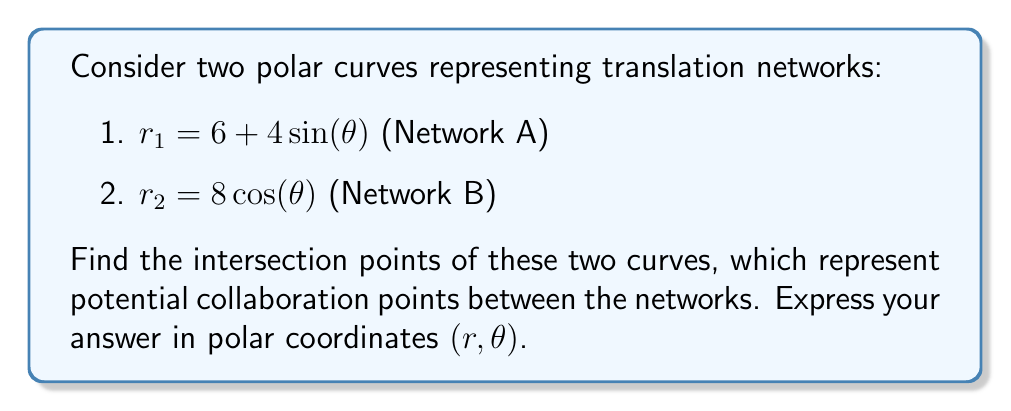Provide a solution to this math problem. To find the intersection points of these two polar curves, we need to solve the equation:

$$6 + 4\sin(\theta) = 8\cos(\theta)$$

Let's approach this step-by-step:

1) First, we rearrange the equation:
   $$6 = 8\cos(\theta) - 4\sin(\theta)$$

2) Divide both sides by 2:
   $$3 = 4\cos(\theta) - 2\sin(\theta)$$

3) We can use the trigonometric identity $a\cos(\theta) + b\sin(\theta) = R\cos(\theta - \alpha)$, where $R = \sqrt{a^2 + b^2}$ and $\tan(\alpha) = \frac{b}{a}$.

4) In our case, $a = 4$, $b = -2$:
   $$R = \sqrt{4^2 + (-2)^2} = \sqrt{20} = 2\sqrt{5}$$
   $$\tan(\alpha) = \frac{-2}{4} = -\frac{1}{2}$$
   $$\alpha = \arctan(-\frac{1}{2}) \approx -0.4636 \text{ radians}$$

5) Our equation becomes:
   $$3 = 2\sqrt{5}\cos(\theta + 0.4636)$$

6) Solving for $\theta$:
   $$\cos(\theta + 0.4636) = \frac{3}{2\sqrt{5}}$$
   $$\theta + 0.4636 = \pm \arccos(\frac{3}{2\sqrt{5}})$$
   $$\theta = -0.4636 \pm \arccos(\frac{3}{2\sqrt{5}})$$

7) This gives us two solutions:
   $$\theta_1 = -0.4636 + \arccos(\frac{3}{2\sqrt{5}}) \approx 0.7854 \text{ radians} = 45°$$
   $$\theta_2 = -0.4636 - \arccos(\frac{3}{2\sqrt{5}}) \approx -1.7126 \text{ radians} = -98.13°$$

8) To find the corresponding $r$ values, we can use either of the original equations. Let's use $r_1 = 6 + 4\sin(\theta)$:
   For $\theta_1$: $r_1 = 6 + 4\sin(45°) = 6 + 4 \cdot \frac{\sqrt{2}}{2} = 6 + 2\sqrt{2} \approx 8.8284$
   For $\theta_2$: $r_2 = 6 + 4\sin(-98.13°) \approx 2.8284$

Therefore, the intersection points are approximately $(8.8284, 45°)$ and $(2.8284, -98.13°)$ in polar coordinates $(r, \theta)$.
Answer: The intersection points are approximately $(8.8284, 45°)$ and $(2.8284, -98.13°)$ in polar coordinates $(r, \theta)$. 